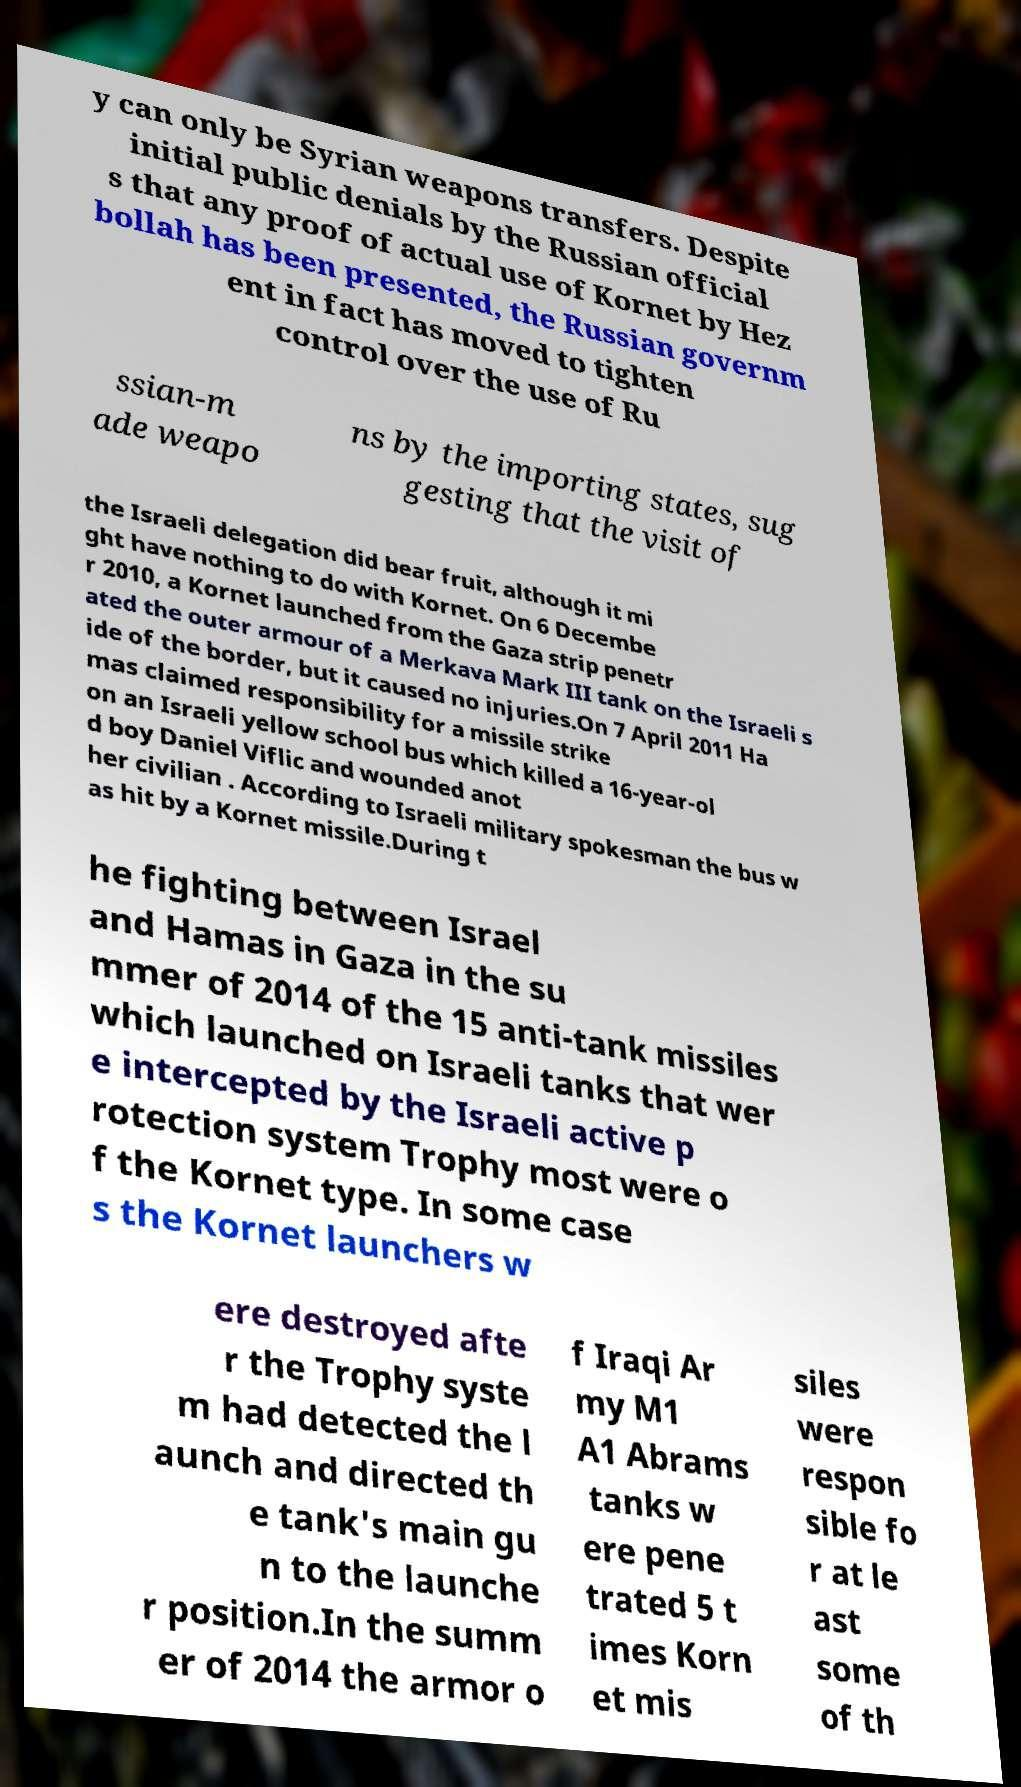Can you accurately transcribe the text from the provided image for me? y can only be Syrian weapons transfers. Despite initial public denials by the Russian official s that any proof of actual use of Kornet by Hez bollah has been presented, the Russian governm ent in fact has moved to tighten control over the use of Ru ssian-m ade weapo ns by the importing states, sug gesting that the visit of the Israeli delegation did bear fruit, although it mi ght have nothing to do with Kornet. On 6 Decembe r 2010, a Kornet launched from the Gaza strip penetr ated the outer armour of a Merkava Mark III tank on the Israeli s ide of the border, but it caused no injuries.On 7 April 2011 Ha mas claimed responsibility for a missile strike on an Israeli yellow school bus which killed a 16-year-ol d boy Daniel Viflic and wounded anot her civilian . According to Israeli military spokesman the bus w as hit by a Kornet missile.During t he fighting between Israel and Hamas in Gaza in the su mmer of 2014 of the 15 anti-tank missiles which launched on Israeli tanks that wer e intercepted by the Israeli active p rotection system Trophy most were o f the Kornet type. In some case s the Kornet launchers w ere destroyed afte r the Trophy syste m had detected the l aunch and directed th e tank's main gu n to the launche r position.In the summ er of 2014 the armor o f Iraqi Ar my M1 A1 Abrams tanks w ere pene trated 5 t imes Korn et mis siles were respon sible fo r at le ast some of th 